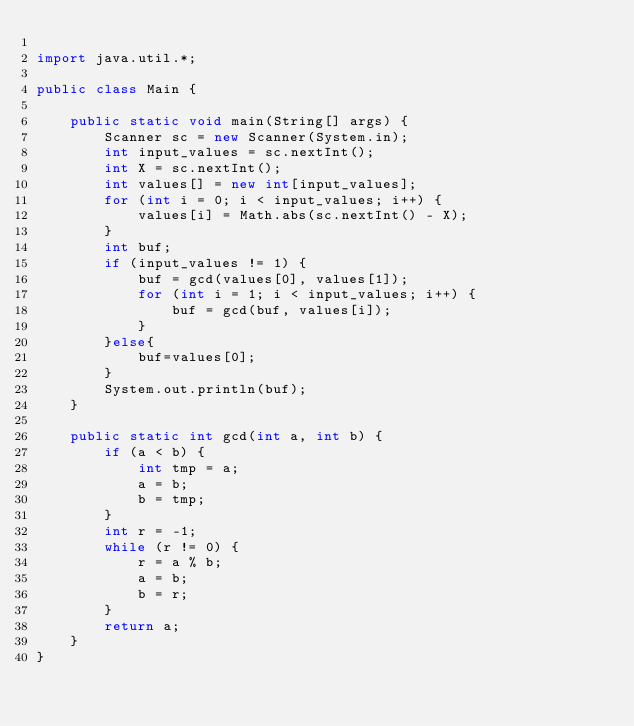<code> <loc_0><loc_0><loc_500><loc_500><_Java_>
import java.util.*;

public class Main {

    public static void main(String[] args) {
        Scanner sc = new Scanner(System.in);
        int input_values = sc.nextInt();
        int X = sc.nextInt();
        int values[] = new int[input_values];
        for (int i = 0; i < input_values; i++) {
            values[i] = Math.abs(sc.nextInt() - X);
        }
        int buf;
        if (input_values != 1) {
            buf = gcd(values[0], values[1]);
            for (int i = 1; i < input_values; i++) {
                buf = gcd(buf, values[i]);
            }
        }else{
            buf=values[0];
        }
        System.out.println(buf);
    }

    public static int gcd(int a, int b) {
        if (a < b) {
            int tmp = a;
            a = b;
            b = tmp;
        }
        int r = -1;
        while (r != 0) {
            r = a % b;
            a = b;
            b = r;
        }
        return a;
    }
}
</code> 